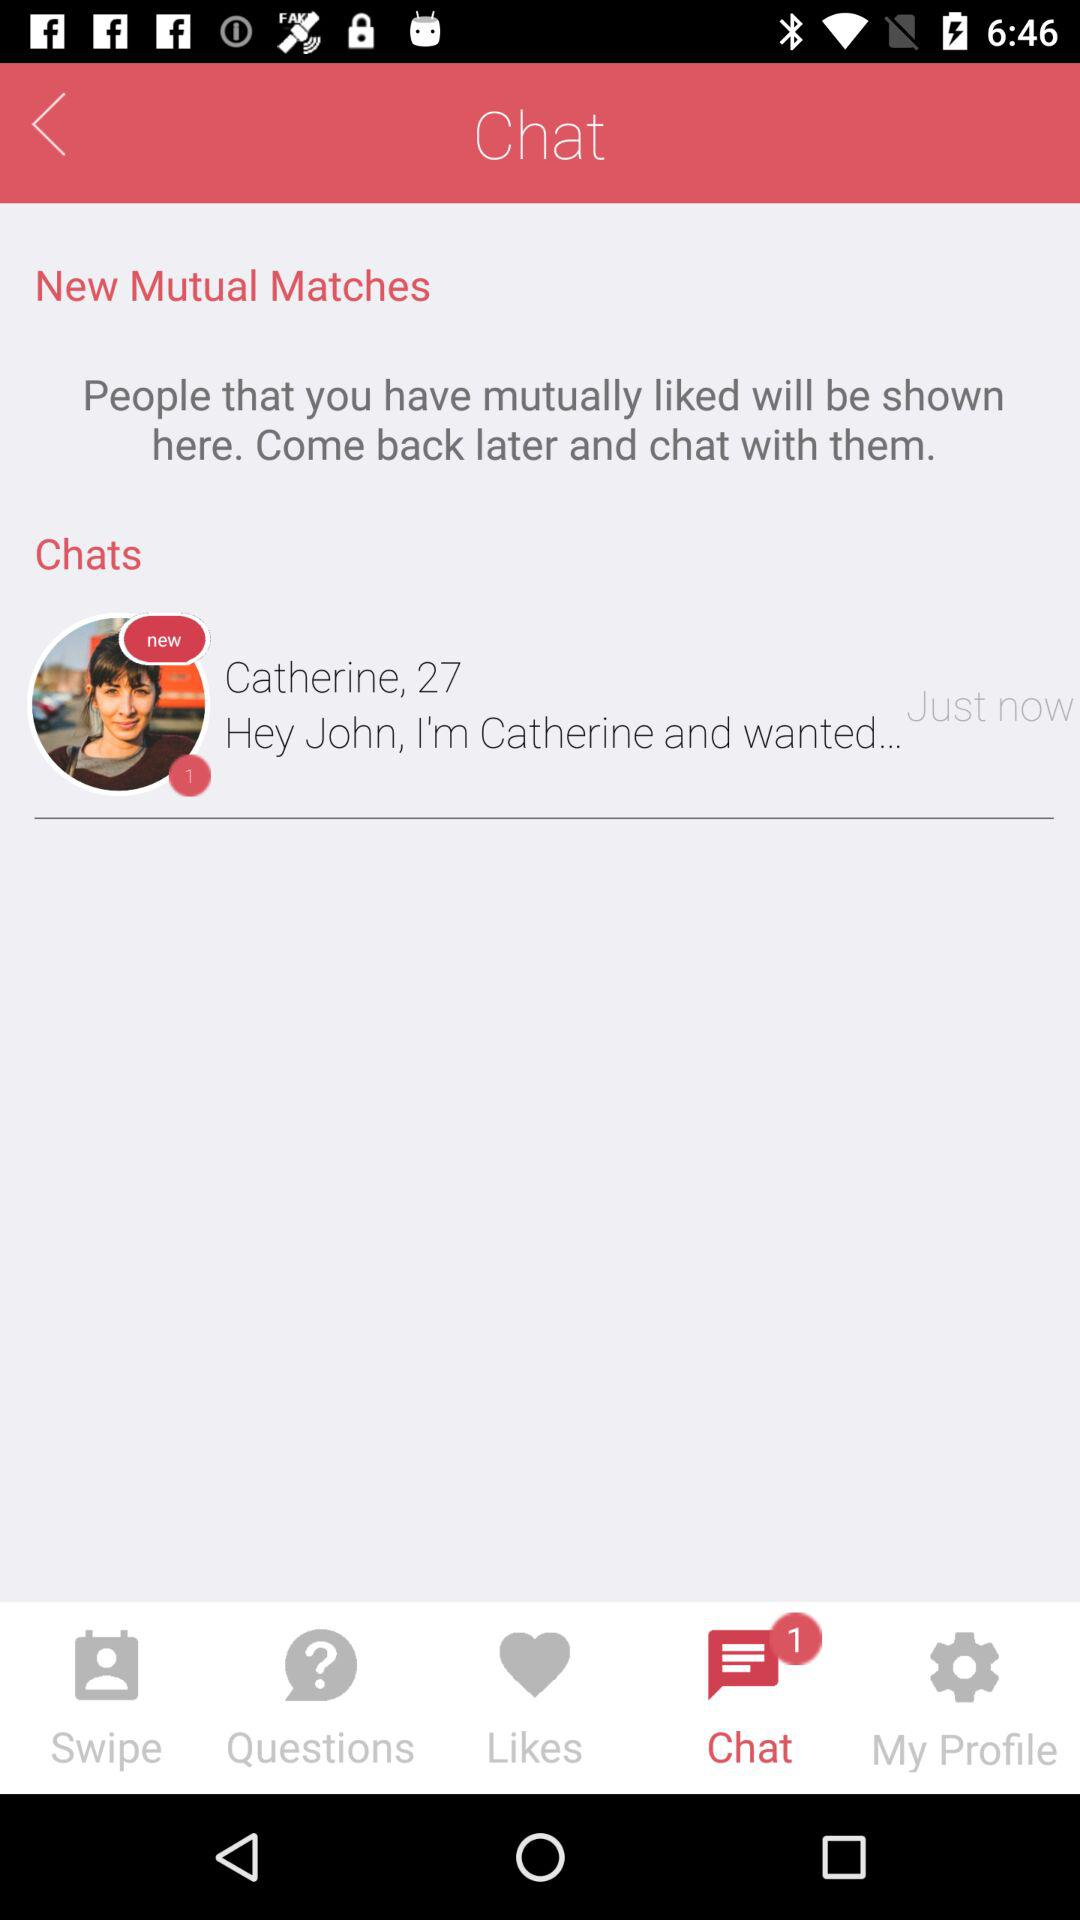How many unread messages does Catherine have?
Answer the question using a single word or phrase. 1 